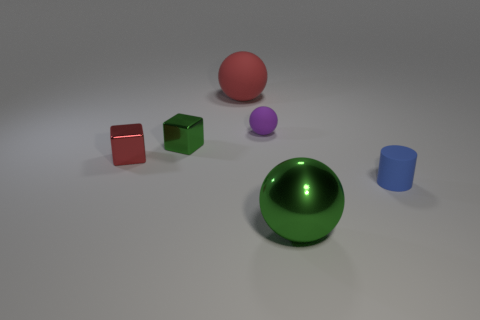Add 1 small rubber objects. How many objects exist? 7 Subtract all blocks. How many objects are left? 4 Subtract all red things. Subtract all shiny cubes. How many objects are left? 2 Add 1 large red matte objects. How many large red matte objects are left? 2 Add 1 yellow rubber cylinders. How many yellow rubber cylinders exist? 1 Subtract 1 green cubes. How many objects are left? 5 